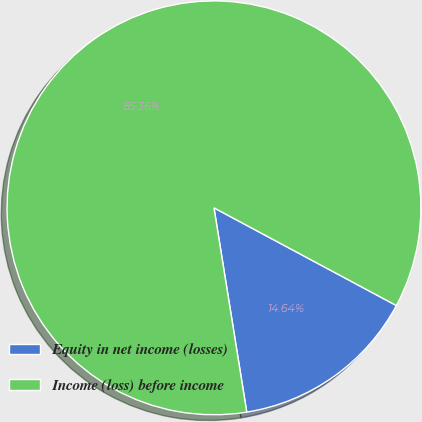Convert chart. <chart><loc_0><loc_0><loc_500><loc_500><pie_chart><fcel>Equity in net income (losses)<fcel>Income (loss) before income<nl><fcel>14.64%<fcel>85.36%<nl></chart> 